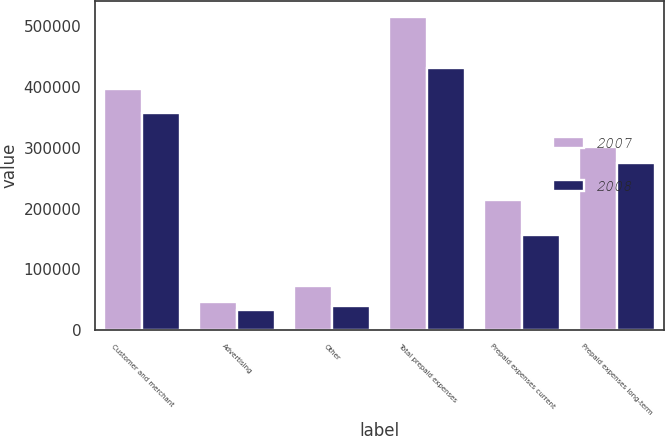Convert chart. <chart><loc_0><loc_0><loc_500><loc_500><stacked_bar_chart><ecel><fcel>Customer and merchant<fcel>Advertising<fcel>Other<fcel>Total prepaid expenses<fcel>Prepaid expenses current<fcel>Prepaid expenses long-term<nl><fcel>2007<fcel>397563<fcel>45608<fcel>72536<fcel>515707<fcel>213612<fcel>302095<nl><fcel>2008<fcel>357761<fcel>33603<fcel>39856<fcel>431220<fcel>156258<fcel>274962<nl></chart> 